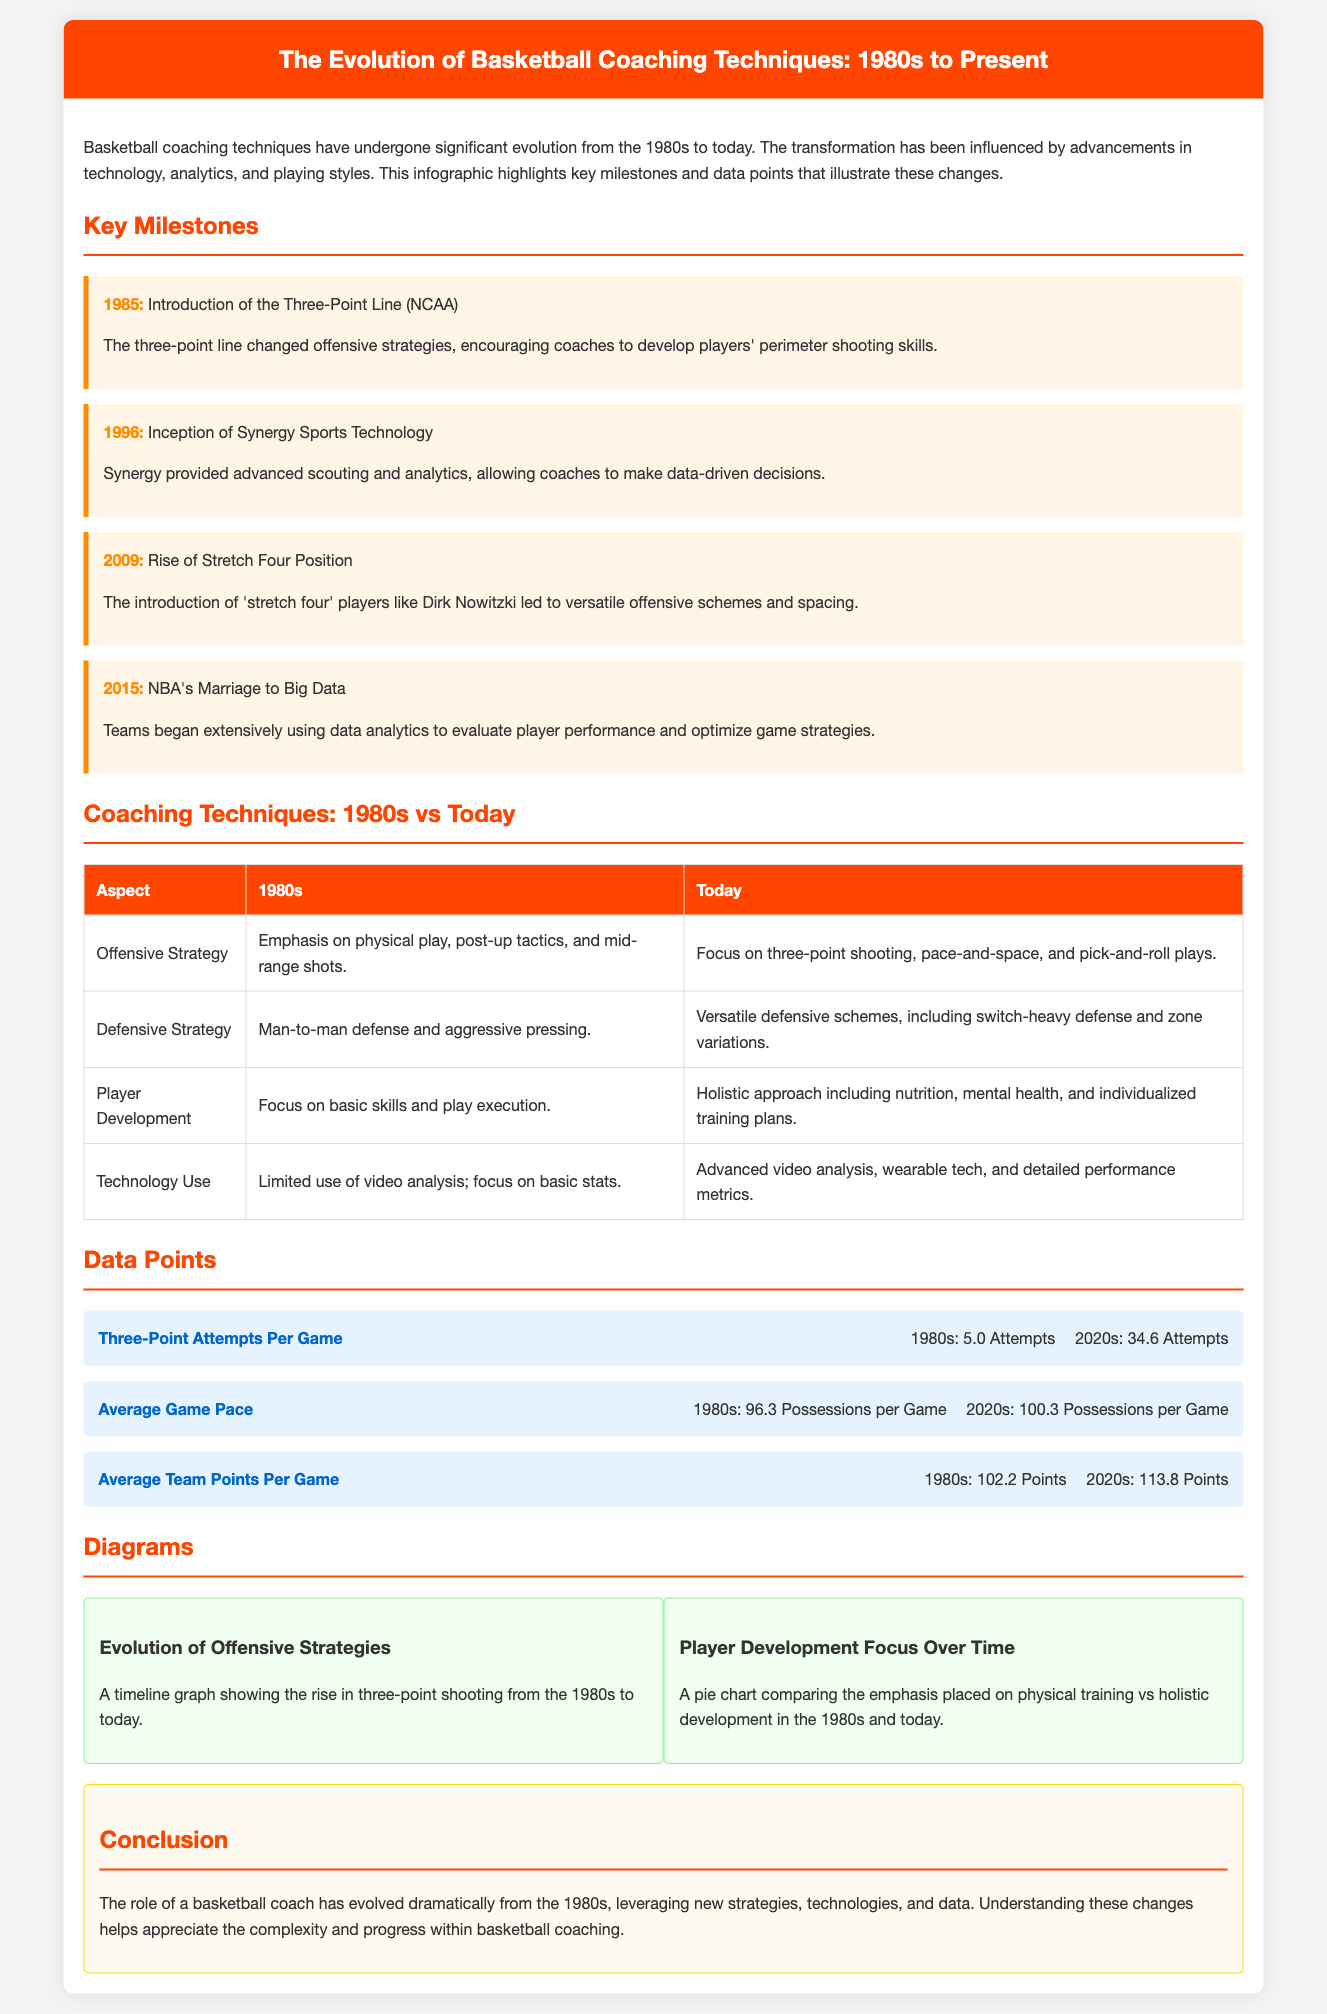What year was the three-point line introduced in NCAA? The document states that the three-point line was introduced in 1985.
Answer: 1985 What technology was founded in 1996 that influences basketball coaching? The infographic mentions the inception of Synergy Sports Technology in 1996.
Answer: Synergy Sports Technology How many three-point attempts per game were there in the 1980s? The document provides that in the 1980s, there were 5.0 three-point attempts per game.
Answer: 5.0 Attempts What is the average points scored per game in the 2020s? According to the infographic, the average points scored per game in the 2020s is 113.8.
Answer: 113.8 Points What significant change occurred around 2009? The rise of the stretch four position is highlighted as a significant change in 2009.
Answer: Stretch Four Position Describe the focus of player development techniques today. The document refers to a holistic approach including nutrition, mental health, and individualized training plans.
Answer: Holistic approach Which category saw an increase in emphasis from the 1980s to today according to the pie chart? The pie chart compares physical training vs holistic development, where holistic development gained emphasis.
Answer: Holistic development What year did the NBA begin to extensively use data analytics? The document states that this milestone occurred in 2015.
Answer: 2015 What is one statistic used to compare game pace between the 1980s and today? Average game pace is mentioned with specific values for the 1980s and 2020s to illustrate the difference.
Answer: 96.3 Possessions per Game 